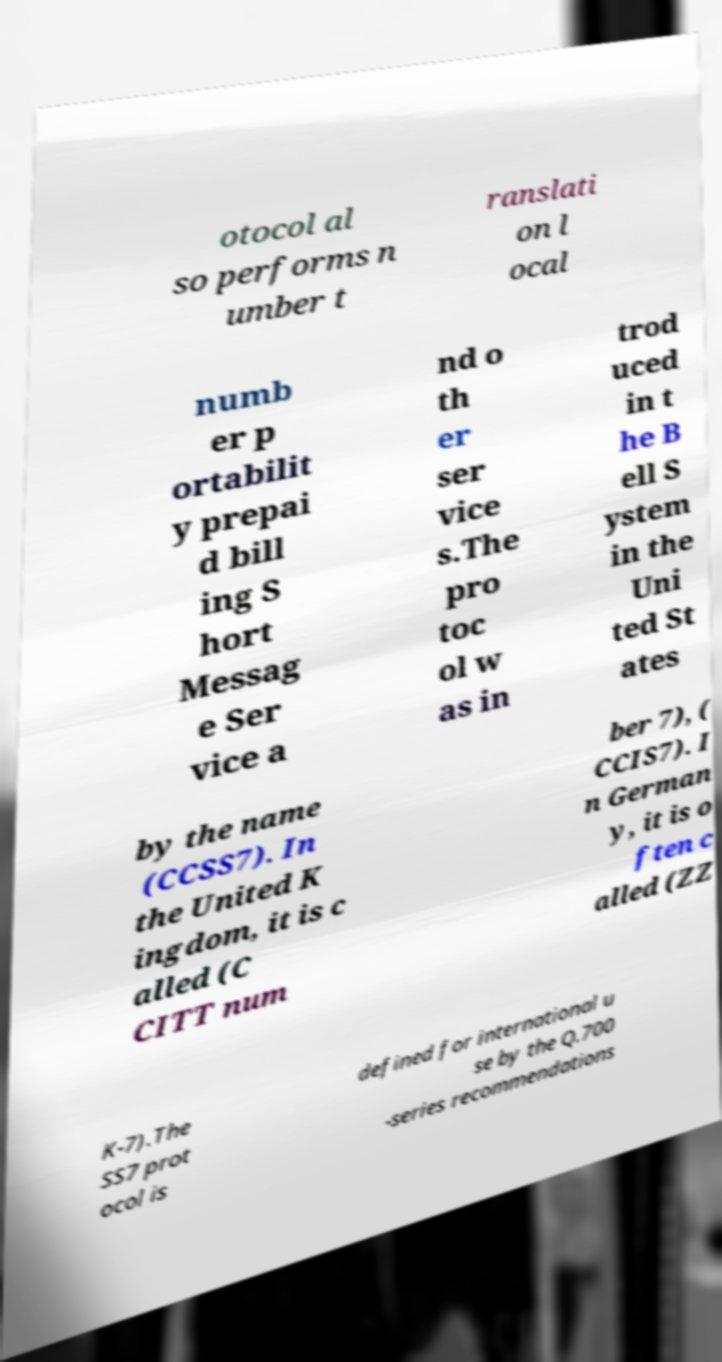Please identify and transcribe the text found in this image. otocol al so performs n umber t ranslati on l ocal numb er p ortabilit y prepai d bill ing S hort Messag e Ser vice a nd o th er ser vice s.The pro toc ol w as in trod uced in t he B ell S ystem in the Uni ted St ates by the name (CCSS7). In the United K ingdom, it is c alled (C CITT num ber 7), ( CCIS7). I n German y, it is o ften c alled (ZZ K-7).The SS7 prot ocol is defined for international u se by the Q.700 -series recommendations 